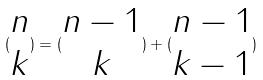Convert formula to latex. <formula><loc_0><loc_0><loc_500><loc_500>( \begin{matrix} n \\ k \end{matrix} ) = ( \begin{matrix} n - 1 \\ k \end{matrix} ) + ( \begin{matrix} n - 1 \\ k - 1 \end{matrix} )</formula> 